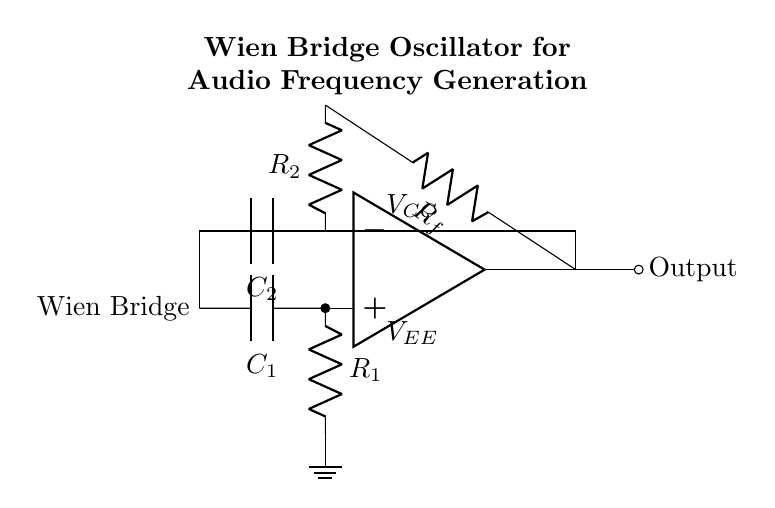what are the components in the circuit? The circuit includes an operational amplifier, two resistors labeled R1 and R2, two capacitors labeled C1 and C2, and a feedback resistor labeled Rf. These components are typical in a Wien bridge oscillator setup.
Answer: operational amplifier, R1, R2, C1, C2, Rf what is the role of the operational amplifier in this circuit? The operational amplifier acts as a voltage amplifier that enables the oscillator to produce an output waveform. It takes the input from the feedback network and amplifies it to sustain oscillations in the circuit.
Answer: voltage amplifier how many resistors are present in the circuit? There are three resistors in the circuit configuration. R1 is connected to the non-inverting terminal, R2 is connected to the inverting terminal, and Rf is part of the feedback loop.
Answer: three what is the purpose of the feedback network? The feedback network, consisting of Rf and the two capacitors, controls the gain of the oscillator. It ensures that the feedback is positive at certain frequencies, allowing oscillations to occur while maintaining stability.
Answer: control gain how does the Wien bridge oscillator achieve frequency stability? The Wien bridge oscillator achieves frequency stability through the specific ratio of the resistances R1 and R2 and the capacitances C1 and C2, which determines the frequency of oscillation. A balance in the circuit maintains the desired frequency while using feedback for fine-tuning.
Answer: specific resistance and capacitance ratio what is the output type of this oscillator circuit? The output of this Wien bridge oscillator circuit is typically a sine wave, suitable for audio frequency applications like home theater systems, as it generates a smooth waveform necessary for sound reproduction.
Answer: sine wave what happens if one of the capacitors is removed from the circuit? If one of the capacitors is removed, the circuit may not oscillate at all or the frequency will change significantly, as the capacitors play a crucial role in setting the frequency of oscillation; without them, the required phase shift for oscillation could be disrupted.
Answer: may not oscillate 